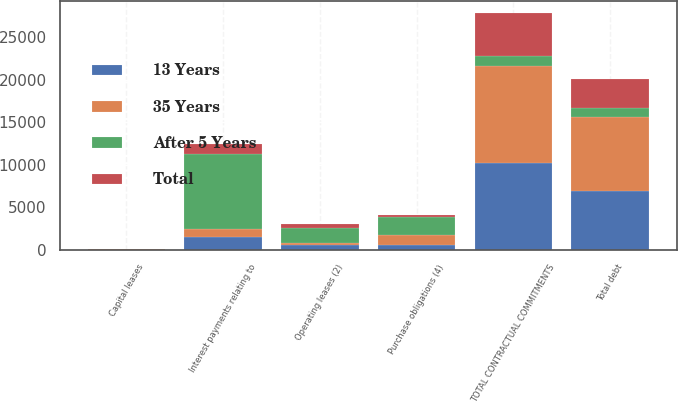<chart> <loc_0><loc_0><loc_500><loc_500><stacked_bar_chart><ecel><fcel>Total debt<fcel>Capital leases<fcel>Interest payments relating to<fcel>Operating leases (2)<fcel>Purchase obligations (4)<fcel>TOTAL CONTRACTUAL COMMITMENTS<nl><fcel>After 5 Years<fcel>1132<fcel>45<fcel>8866<fcel>1817<fcel>2187<fcel>1132<nl><fcel>35 Years<fcel>8672<fcel>16<fcel>909<fcel>289<fcel>1094<fcel>11365<nl><fcel>13 Years<fcel>6927<fcel>14<fcel>1546<fcel>498<fcel>596<fcel>10261<nl><fcel>Total<fcel>3356<fcel>14<fcel>1170<fcel>393<fcel>215<fcel>5148<nl></chart> 